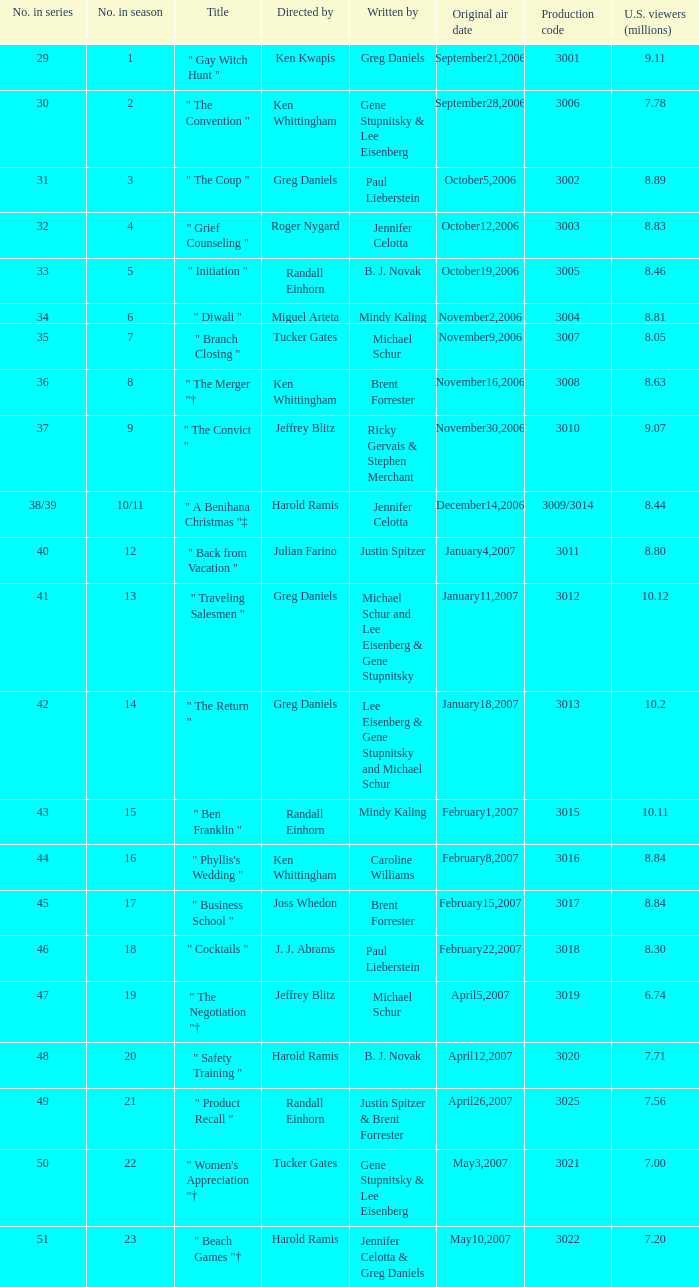Name the number in the series for when the viewers is 7.78 30.0. 